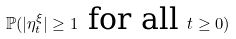<formula> <loc_0><loc_0><loc_500><loc_500>\mathbb { P } ( | \eta ^ { \xi } _ { t } | \geq 1 \text { for all } t \geq 0 )</formula> 